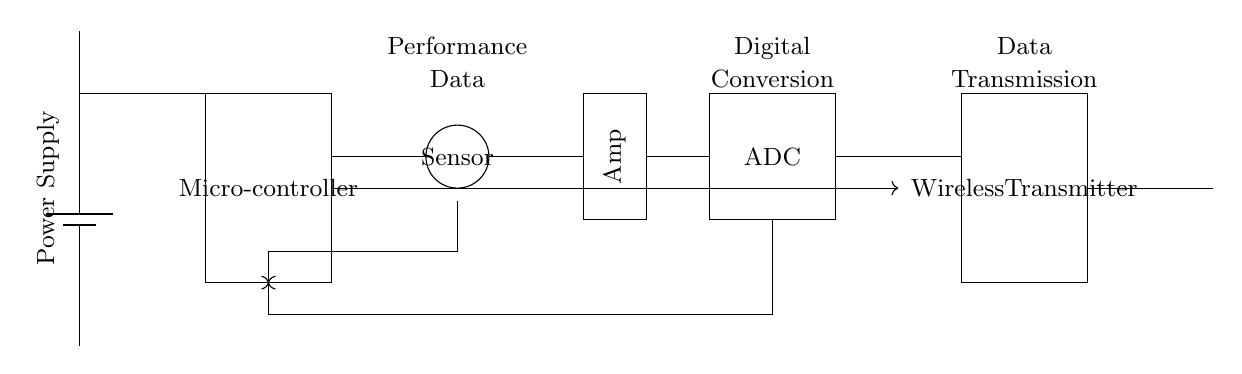What is the purpose of the microcontroller in this circuit? The microcontroller acts as the central processing unit to gather data from the sensor, process it, and control the flow of data through the circuit, particularly to the ADC and wireless transmitter.
Answer: Data processing What type of data does the sensor collect? The sensor typically collects performance data related to the athlete, such as heart rate, speed, or distance. The specific type of data depends on the sensor used in this context.
Answer: Performance data What is the function of the ADC in this circuit? The ADC converts the analog signals from the sensor into digital data that can be processed by the microcontroller. This is crucial for further data analysis and transmission.
Answer: Digital conversion How is data transmitted from the circuit? Data is transmitted wirelessly from the microcontroller to the antenna via the wireless transmitter, which allows for real-time tracking of the athlete’s performance.
Answer: Wireless transmission What is the connection between the amplifier and the ADC? The amplifier processes the analog signals from the sensor to ensure that they are at a suitable level before being converted to digital form by the ADC, enhancing the fidelity of the data captured.
Answer: Signal processing What component powers the circuit? The circuit is powered by a battery, which provides the necessary voltage for all components to function, ensuring proper operation of the sensor, microcontroller, and other parts.
Answer: Battery How many main components are present in the circuit? The circuit consists of six main components: power supply, microcontroller, sensor, amplifier, ADC, and wireless transmitter. Each plays a unique role in the data transmission process.
Answer: Six 